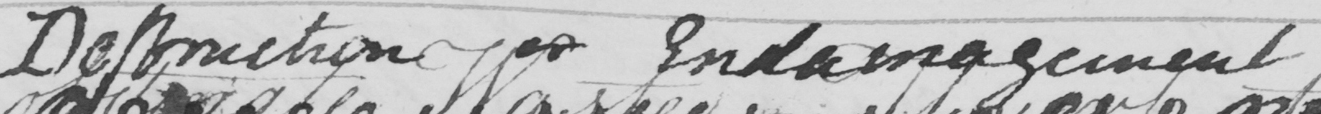What is written in this line of handwriting? Destruction or Endamagement . 